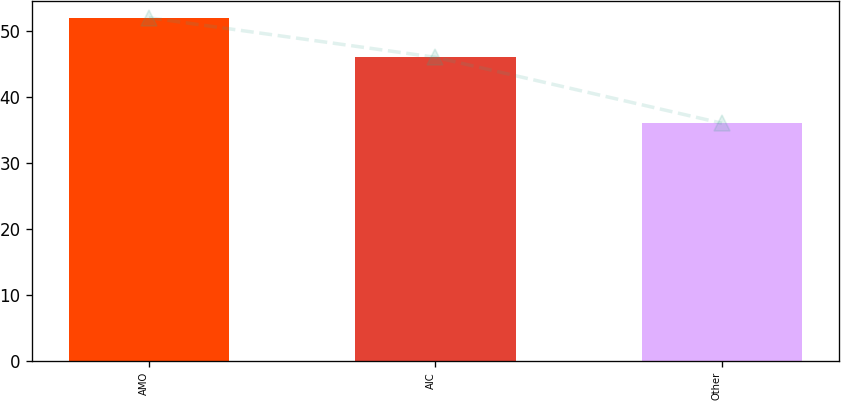<chart> <loc_0><loc_0><loc_500><loc_500><bar_chart><fcel>AMO<fcel>AIC<fcel>Other<nl><fcel>52<fcel>46<fcel>36<nl></chart> 